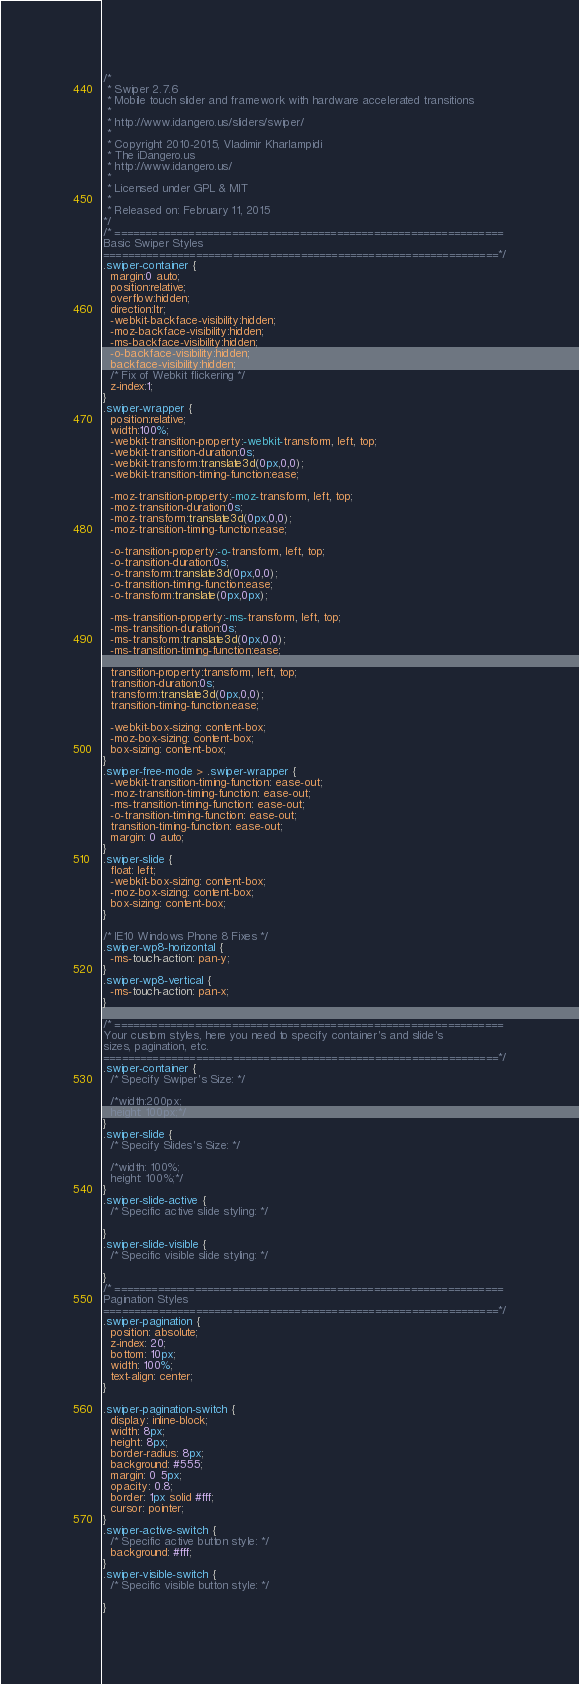<code> <loc_0><loc_0><loc_500><loc_500><_CSS_>/*
 * Swiper 2.7.6
 * Mobile touch slider and framework with hardware accelerated transitions
 *
 * http://www.idangero.us/sliders/swiper/
 *
 * Copyright 2010-2015, Vladimir Kharlampidi
 * The iDangero.us
 * http://www.idangero.us/
 *
 * Licensed under GPL & MIT
 *
 * Released on: February 11, 2015
*/
/* ===============================================================
Basic Swiper Styles 
================================================================*/
.swiper-container {
  margin:0 auto;
  position:relative;
  overflow:hidden;
  direction:ltr;
  -webkit-backface-visibility:hidden;
  -moz-backface-visibility:hidden;
  -ms-backface-visibility:hidden;
  -o-backface-visibility:hidden;
  backface-visibility:hidden;
  /* Fix of Webkit flickering */
  z-index:1;
}
.swiper-wrapper {
  position:relative;
  width:100%;
  -webkit-transition-property:-webkit-transform, left, top;
  -webkit-transition-duration:0s;
  -webkit-transform:translate3d(0px,0,0);
  -webkit-transition-timing-function:ease;
  
  -moz-transition-property:-moz-transform, left, top;
  -moz-transition-duration:0s;
  -moz-transform:translate3d(0px,0,0);
  -moz-transition-timing-function:ease;
  
  -o-transition-property:-o-transform, left, top;
  -o-transition-duration:0s;
  -o-transform:translate3d(0px,0,0);
  -o-transition-timing-function:ease;
  -o-transform:translate(0px,0px);
  
  -ms-transition-property:-ms-transform, left, top;
  -ms-transition-duration:0s;
  -ms-transform:translate3d(0px,0,0);
  -ms-transition-timing-function:ease;
  
  transition-property:transform, left, top;
  transition-duration:0s;
  transform:translate3d(0px,0,0);
  transition-timing-function:ease;

  -webkit-box-sizing: content-box;
  -moz-box-sizing: content-box;
  box-sizing: content-box;
}
.swiper-free-mode > .swiper-wrapper {
  -webkit-transition-timing-function: ease-out;
  -moz-transition-timing-function: ease-out;
  -ms-transition-timing-function: ease-out;
  -o-transition-timing-function: ease-out;
  transition-timing-function: ease-out;
  margin: 0 auto;
}
.swiper-slide {
  float: left;
  -webkit-box-sizing: content-box;
  -moz-box-sizing: content-box;
  box-sizing: content-box;
}

/* IE10 Windows Phone 8 Fixes */
.swiper-wp8-horizontal {
  -ms-touch-action: pan-y;
}
.swiper-wp8-vertical {
  -ms-touch-action: pan-x;
}

/* ===============================================================
Your custom styles, here you need to specify container's and slide's
sizes, pagination, etc.
================================================================*/
.swiper-container {
  /* Specify Swiper's Size: */

  /*width:200px;
  height: 100px;*/
}
.swiper-slide {
  /* Specify Slides's Size: */
  
  /*width: 100%;
  height: 100%;*/
}
.swiper-slide-active {
  /* Specific active slide styling: */
  
}
.swiper-slide-visible {
  /* Specific visible slide styling: */ 

}
/* ===============================================================
Pagination Styles
================================================================*/
.swiper-pagination {
  position: absolute;
  z-index: 20;
  bottom: 10px;
  width: 100%;
  text-align: center;
}

.swiper-pagination-switch {
  display: inline-block;
  width: 8px;
  height: 8px;
  border-radius: 8px;
  background: #555;
  margin: 0 5px;
  opacity: 0.8;
  border: 1px solid #fff;
  cursor: pointer;
}
.swiper-active-switch {
  /* Specific active button style: */ 
  background: #fff;
}
.swiper-visible-switch {
  /* Specific visible button style: */  
  
}
</code> 